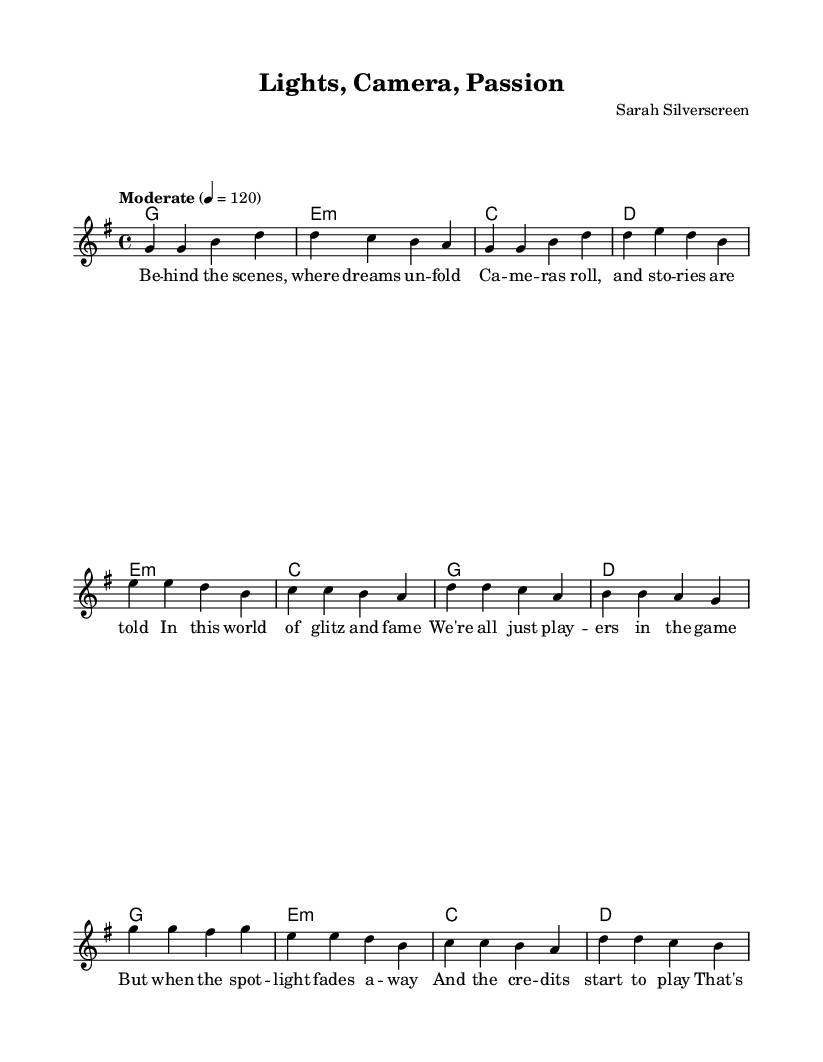What is the key signature of this music? The key signature is G major, which has one sharp (F#). This can be determined by looking at the key signature notation at the beginning of the staff, indicating it is G major.
Answer: G major What is the time signature of this music? The time signature is 4/4, which indicates that there are four beats in a measure and that a quarter note receives one beat. This is noted at the start of the score, showing the division of beats.
Answer: 4/4 What is the tempo marking for this piece? The tempo marking is "Moderate" with a metronome marking of 120 beats per minute. This is indicated in the score, providing guidance on the speed at which the music should be played.
Answer: Moderate 4 = 120 How many measures are in the chorus section? There are four measures in the chorus section, which can be counted directly by reviewing the notation in the chorus part of the score, where the melody and harmonies are presented.
Answer: 4 What musical form does this song follow? The structure follows a verse-pre-chorus-chorus format, common in pop music, as evidenced by the clear labels and progression from verse to pre-chorus and then to the chorus in the score.
Answer: Verse-Pre-Chorus-Chorus What is the first note of the melody? The first note of the melody is G, which can be identified by looking at the first note in the melody staff where the notes are written.
Answer: G What is the primary theme reflected in the lyrics? The primary theme is about behind-the-scenes experiences in film and the illusions of fame, which can be inferred from the lyrics presented in the score, emphasizing the cinematic perspective.
Answer: Behind-the-scenes 